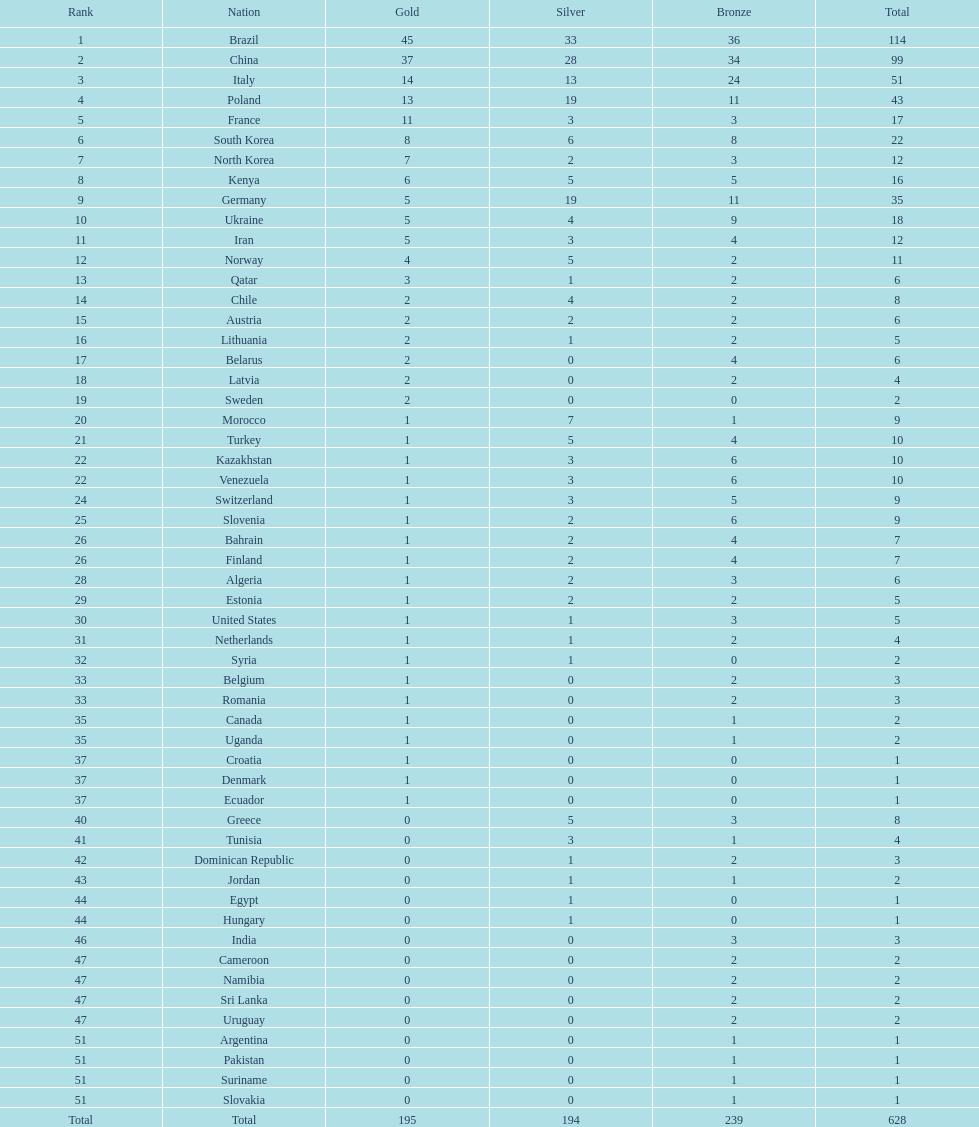Who secured only 13 silver medals? Italy. 